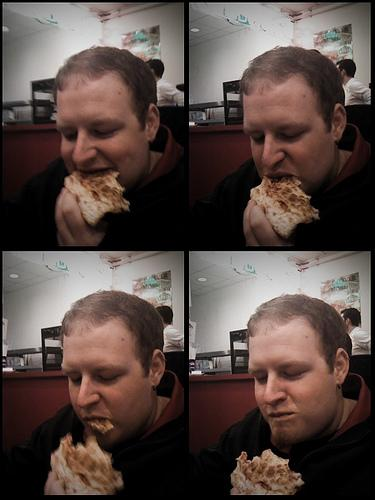Describe any interactions between objects or people in the image. The main man in the image is interacting with a slice of pizza by taking a bite and chewing it, while there's another person behind a red counter in the background. Express what the man is doing in the picture. The man is taking a bite of pizza and chewing it while eating. Point out a detail about the shirt worn by the man. The shirt features a red collar. Who seems to be in the background of the image? There is a person wearing a white shirt in the background. What is a prominent feature of the man in this image? The man has brown hair and is wearing a shirt. What type of food can be seen in this image? There are multiple slices of pizza present in the image. What is the state of the wall in the background of the image? The wall is painted white. Is the person in the image wearing any accessories? If so, what kind? Yes, the man is wearing an earring in his ear. Identify the color and type of bread depicted in the image. There are brown pieces of bread in the image. Estimate the number of people present in the image. There are at least two people in the image, though part of a third person may be obscured. 